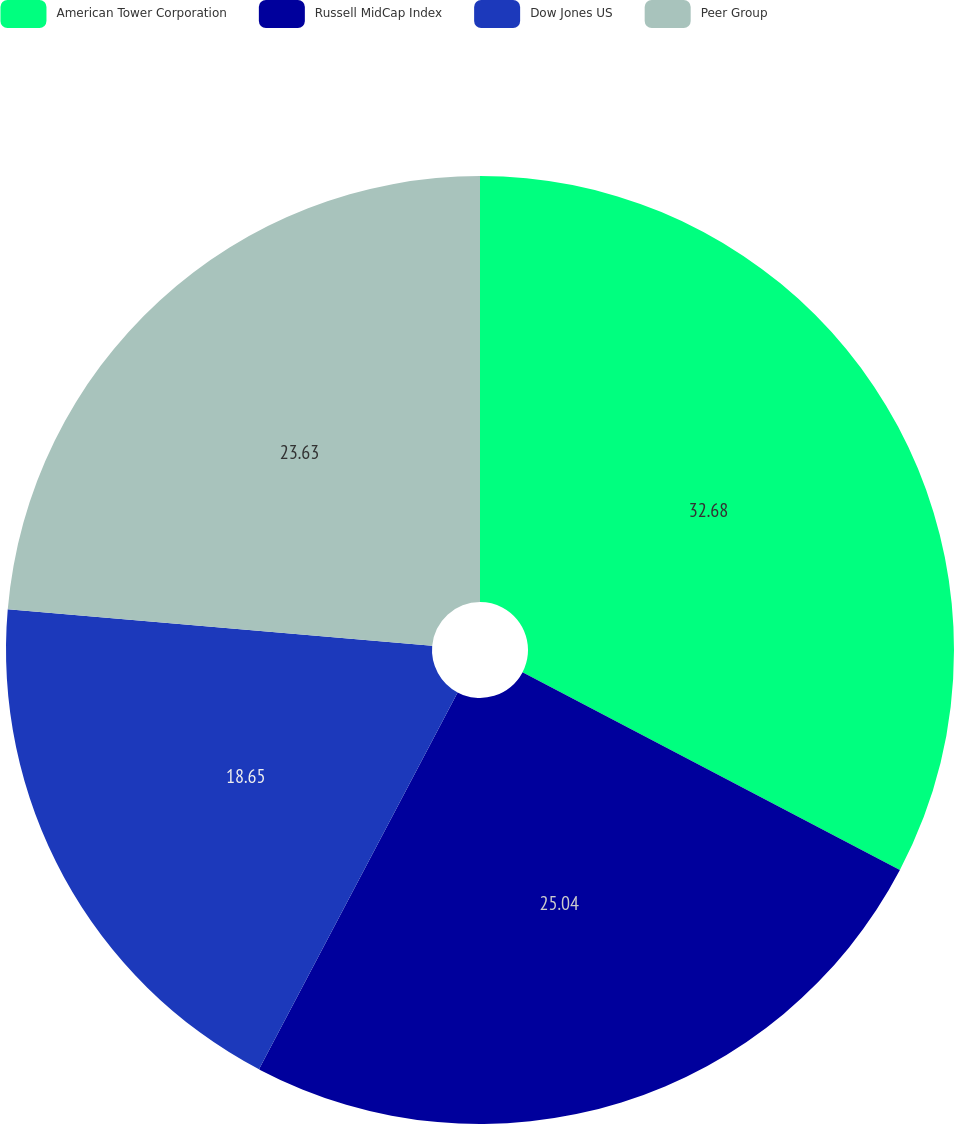Convert chart. <chart><loc_0><loc_0><loc_500><loc_500><pie_chart><fcel>American Tower Corporation<fcel>Russell MidCap Index<fcel>Dow Jones US<fcel>Peer Group<nl><fcel>32.68%<fcel>25.04%<fcel>18.65%<fcel>23.63%<nl></chart> 